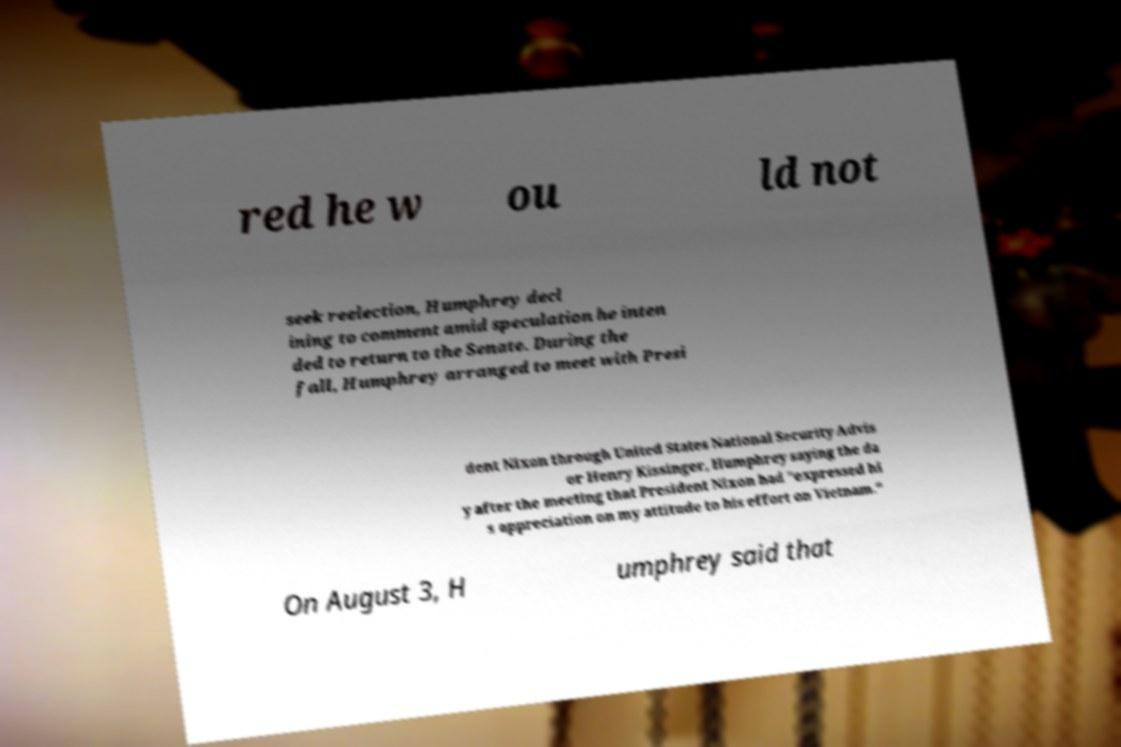Please read and relay the text visible in this image. What does it say? red he w ou ld not seek reelection, Humphrey decl ining to comment amid speculation he inten ded to return to the Senate. During the fall, Humphrey arranged to meet with Presi dent Nixon through United States National Security Advis or Henry Kissinger, Humphrey saying the da y after the meeting that President Nixon had "expressed hi s appreciation on my attitude to his effort on Vietnam." On August 3, H umphrey said that 